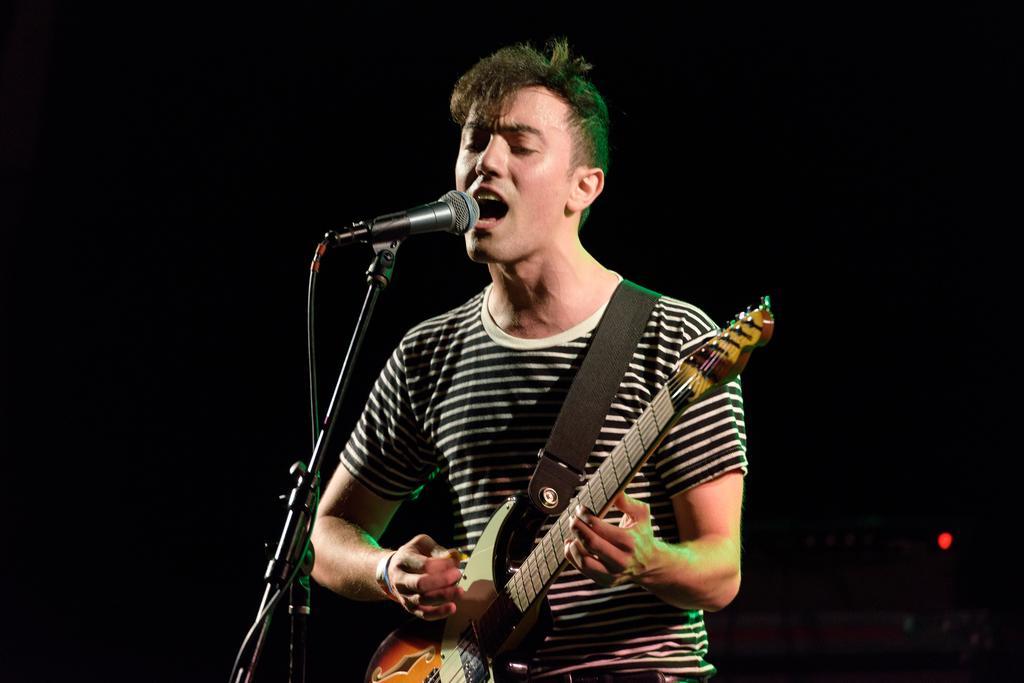In one or two sentences, can you explain what this image depicts? This is the man wearing T-shirt and standing. He is playing guitar and singing a song. This is the mic attached to the mike stand. 